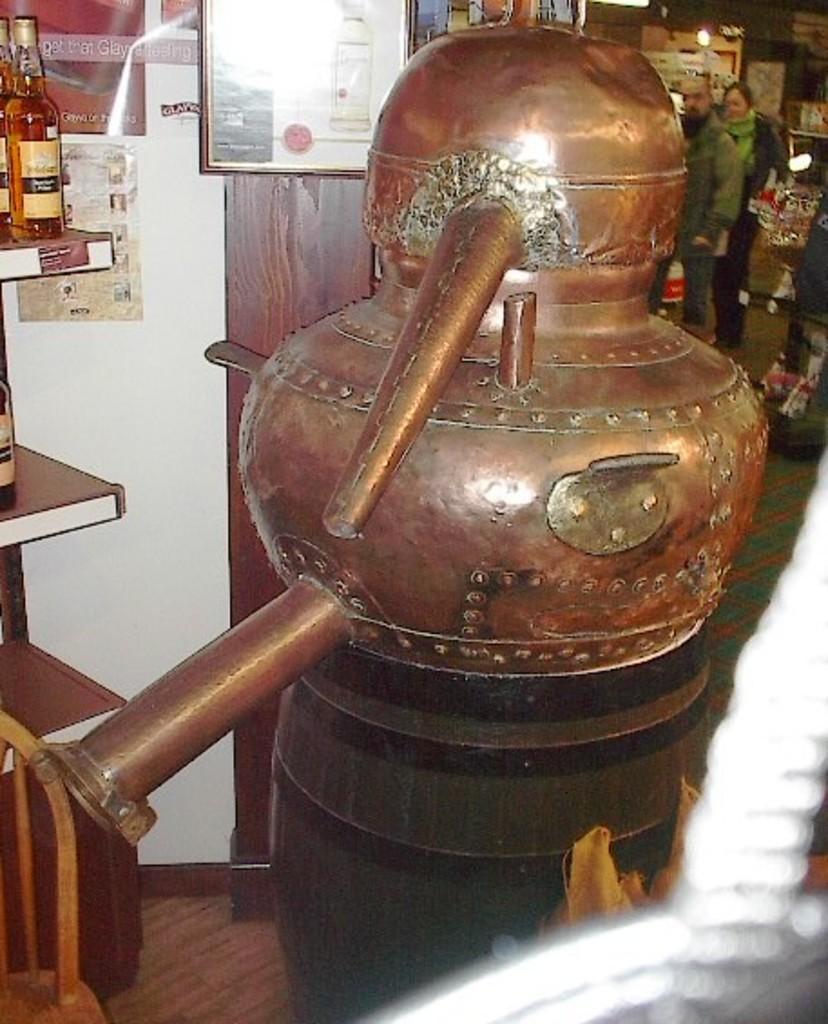Could you give a brief overview of what you see in this image? In this image in front there is an object. Behind the object there is a wooden rack with the wine bottles on it. In front of the wooden rack there is a chair. Behind the wooden rack there's a wall with the posters on it. In the background of the image there are two people standing on the floor. There are lights and a few other objects. 